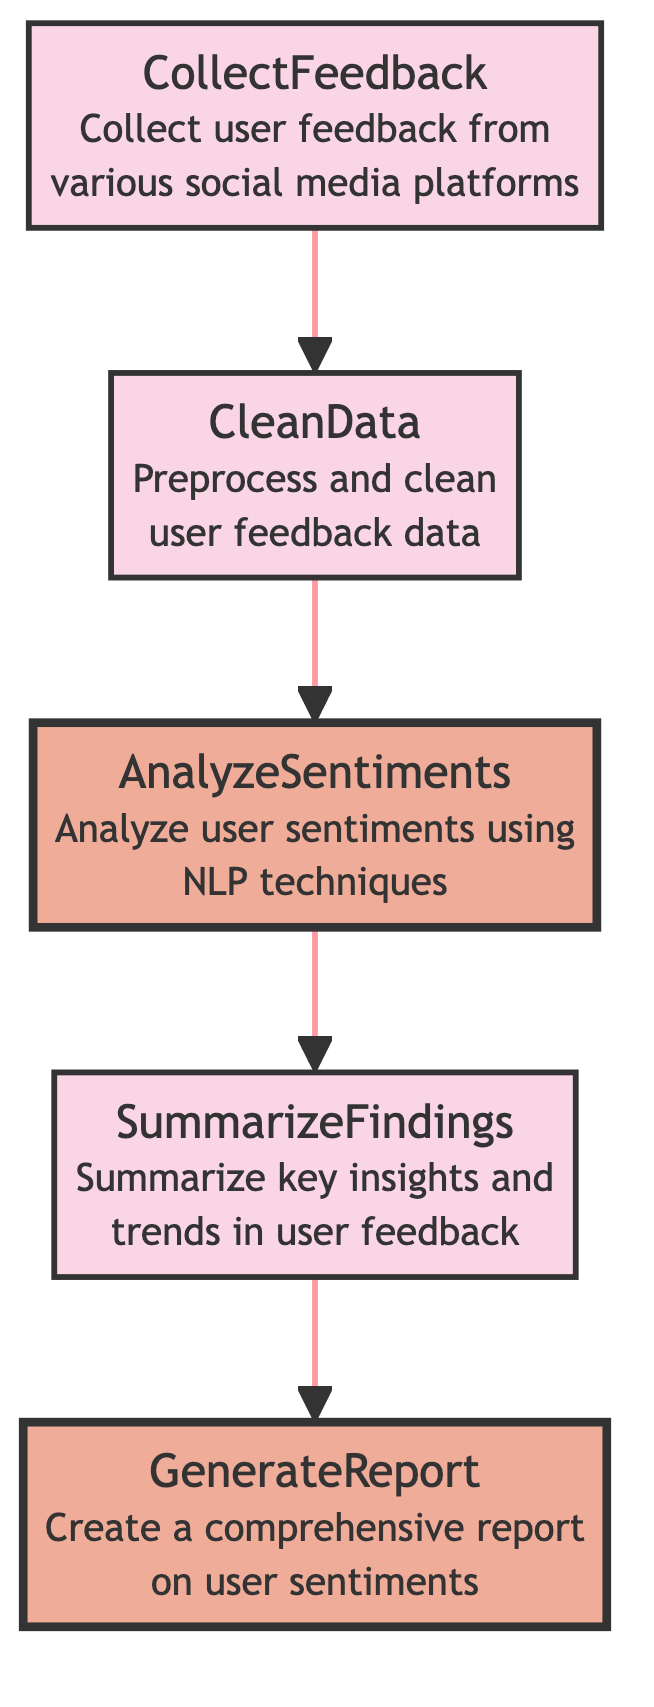What is the first step in the flowchart? The first step is labeled "Collect Feedback", which represents the initiation of the process to gather user feedback. It is the bottommost element in the flowchart and directs the flow to the next step.
Answer: Collect Feedback How many total steps are in the flowchart? There are five steps in the flowchart, which are Collect Feedback, Clean Data, Analyze Sentiments, Summarize Findings, and Generate Report. Counting each distinct step gives the total.
Answer: Five What action follows "Clean Data"? The action following "Clean Data" is "Analyze Sentiments," indicating that once data is cleaned, it will be analyzed for user sentiments. This can be determined by following the directed arrows in the flowchart.
Answer: Analyze Sentiments Which step employs NLP techniques? The step that employs NLP techniques is "Analyze Sentiments," as stated in its description which highlights the use of Natural Language Processing for analyzing user feedback. The flowchart clearly connects this action after data cleaning.
Answer: Analyze Sentiments What is the last action taken in the process? The last action taken in the process is "Generate Report," where a comprehensive report on user sentiments is created. This is at the topmost position in the flowchart, indicating it is the final outcome.
Answer: Generate Report What are the two highlighted steps in the flowchart? The two highlighted steps in the flowchart are "Analyze Sentiments" and "Generate Report". The highlighting indicates these steps may be critical or stand out in the aggregation function. Tracking the style applied to respective steps reveals this information.
Answer: Analyze Sentiments and Generate Report Which step processes the user feedback data? The step that processes the user feedback data is "Clean Data," which is responsible for preprocessing and cleaning the user feedback before analysis. This action is essential for ensuring quality input data for subsequent steps.
Answer: Clean Data What is summarized in the "Summarize Findings" step? The "Summarize Findings" step summarizes key insights and trends derived from the user feedback analyzed in the previous step, providing an overview of the analysis results. This can be interpreted directly from the step's description in the diagram.
Answer: Key insights and trends in user feedback 